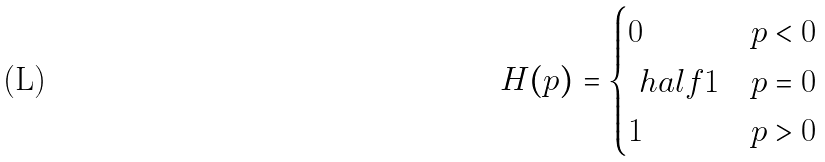Convert formula to latex. <formula><loc_0><loc_0><loc_500><loc_500>H ( p ) = \begin{cases} 0 & p < 0 \\ \ h a l f { 1 } & p = 0 \\ 1 & p > 0 \end{cases}</formula> 